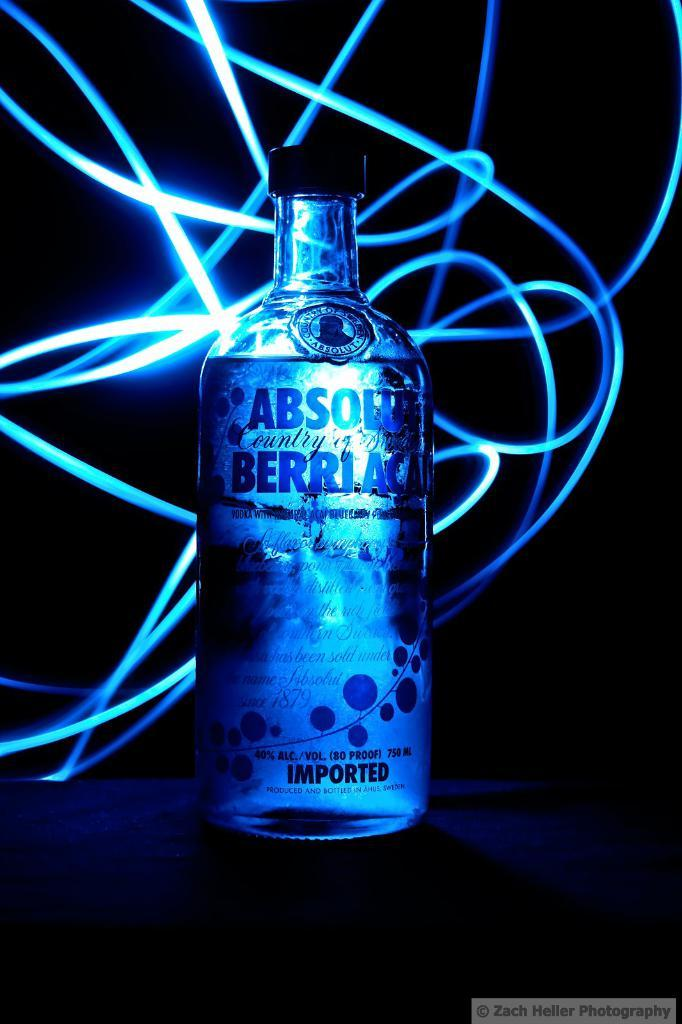<image>
Write a terse but informative summary of the picture. a back lit ad for Absolut Berriac Imported liquor 